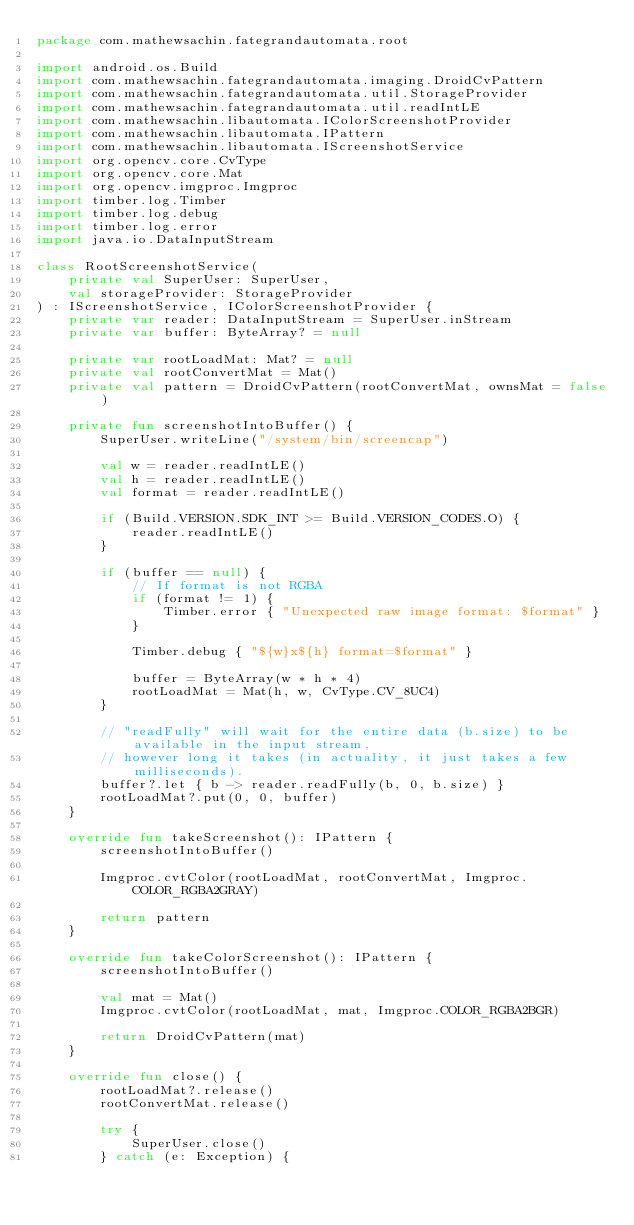Convert code to text. <code><loc_0><loc_0><loc_500><loc_500><_Kotlin_>package com.mathewsachin.fategrandautomata.root

import android.os.Build
import com.mathewsachin.fategrandautomata.imaging.DroidCvPattern
import com.mathewsachin.fategrandautomata.util.StorageProvider
import com.mathewsachin.fategrandautomata.util.readIntLE
import com.mathewsachin.libautomata.IColorScreenshotProvider
import com.mathewsachin.libautomata.IPattern
import com.mathewsachin.libautomata.IScreenshotService
import org.opencv.core.CvType
import org.opencv.core.Mat
import org.opencv.imgproc.Imgproc
import timber.log.Timber
import timber.log.debug
import timber.log.error
import java.io.DataInputStream

class RootScreenshotService(
    private val SuperUser: SuperUser,
    val storageProvider: StorageProvider
) : IScreenshotService, IColorScreenshotProvider {
    private var reader: DataInputStream = SuperUser.inStream
    private var buffer: ByteArray? = null

    private var rootLoadMat: Mat? = null
    private val rootConvertMat = Mat()
    private val pattern = DroidCvPattern(rootConvertMat, ownsMat = false)

    private fun screenshotIntoBuffer() {
        SuperUser.writeLine("/system/bin/screencap")

        val w = reader.readIntLE()
        val h = reader.readIntLE()
        val format = reader.readIntLE()

        if (Build.VERSION.SDK_INT >= Build.VERSION_CODES.O) {
            reader.readIntLE()
        }

        if (buffer == null) {
            // If format is not RGBA
            if (format != 1) {
                Timber.error { "Unexpected raw image format: $format" }
            }

            Timber.debug { "${w}x${h} format=$format" }

            buffer = ByteArray(w * h * 4)
            rootLoadMat = Mat(h, w, CvType.CV_8UC4)
        }

        // "readFully" will wait for the entire data (b.size) to be available in the input stream,
        // however long it takes (in actuality, it just takes a few milliseconds).
        buffer?.let { b -> reader.readFully(b, 0, b.size) }
        rootLoadMat?.put(0, 0, buffer)
    }

    override fun takeScreenshot(): IPattern {
        screenshotIntoBuffer()

        Imgproc.cvtColor(rootLoadMat, rootConvertMat, Imgproc.COLOR_RGBA2GRAY)

        return pattern
    }

    override fun takeColorScreenshot(): IPattern {
        screenshotIntoBuffer()

        val mat = Mat()
        Imgproc.cvtColor(rootLoadMat, mat, Imgproc.COLOR_RGBA2BGR)

        return DroidCvPattern(mat)
    }

    override fun close() {
        rootLoadMat?.release()
        rootConvertMat.release()

        try {
            SuperUser.close()
        } catch (e: Exception) {</code> 